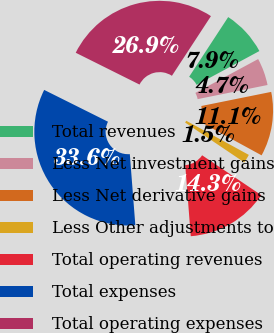Convert chart to OTSL. <chart><loc_0><loc_0><loc_500><loc_500><pie_chart><fcel>Total revenues<fcel>Less Net investment gains<fcel>Less Net derivative gains<fcel>Less Other adjustments to<fcel>Total operating revenues<fcel>Total expenses<fcel>Total operating expenses<nl><fcel>7.91%<fcel>4.7%<fcel>11.12%<fcel>1.49%<fcel>14.33%<fcel>33.6%<fcel>26.86%<nl></chart> 